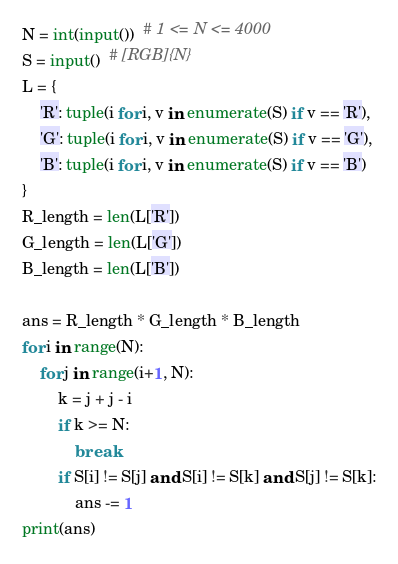Convert code to text. <code><loc_0><loc_0><loc_500><loc_500><_Python_>N = int(input())  # 1 <= N <= 4000
S = input()  # [RGB]{N}
L = {
    'R': tuple(i for i, v in enumerate(S) if v == 'R'),
    'G': tuple(i for i, v in enumerate(S) if v == 'G'),
    'B': tuple(i for i, v in enumerate(S) if v == 'B')
}
R_length = len(L['R'])
G_length = len(L['G'])
B_length = len(L['B'])

ans = R_length * G_length * B_length
for i in range(N):
    for j in range(i+1, N):
        k = j + j - i
        if k >= N:
            break
        if S[i] != S[j] and S[i] != S[k] and S[j] != S[k]:
            ans -= 1
print(ans)



</code> 